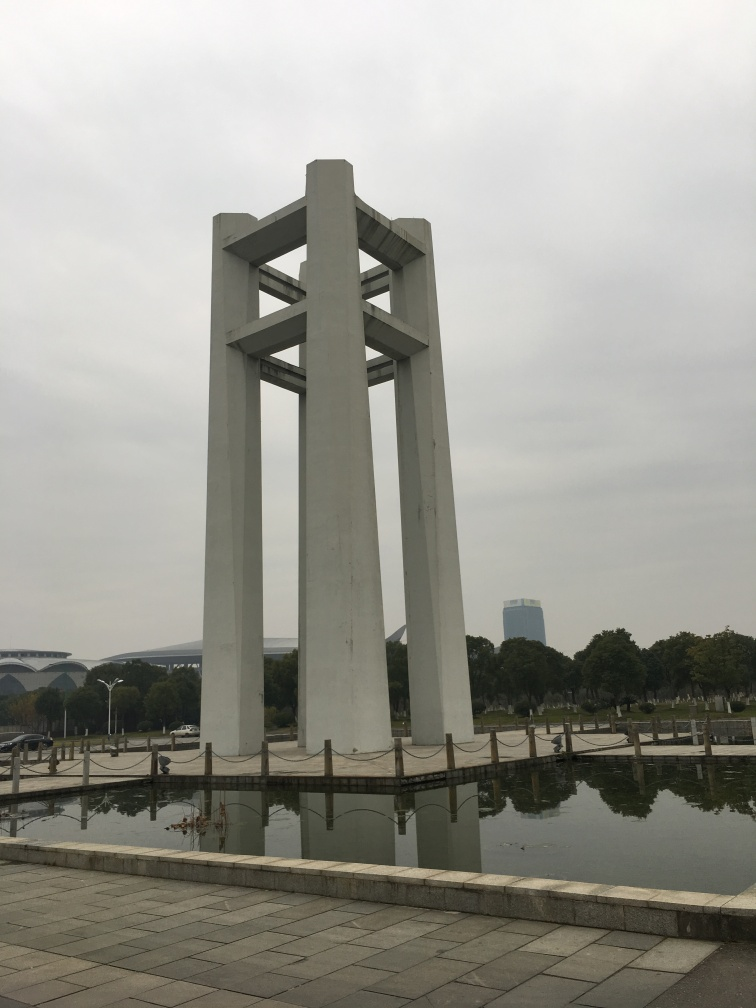What are the characteristics of this image? Upon examining the image, it displays accurate focus, allowing us to clearly observe details such as the texture of the ground and the structure of the buildings. The brightness appears moderate rather than high, as the overcast sky suggests a soft natural light, and the reflection on the water is not overexposed. Thus, we can discern clear ground texture and a visible building structure. 